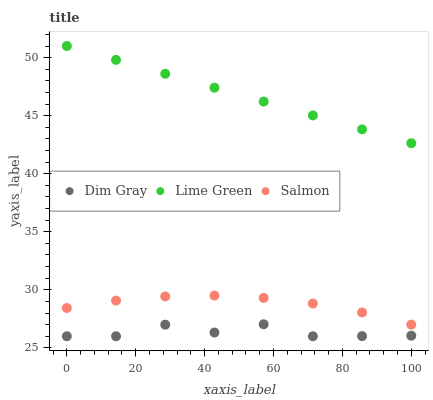Does Dim Gray have the minimum area under the curve?
Answer yes or no. Yes. Does Lime Green have the maximum area under the curve?
Answer yes or no. Yes. Does Lime Green have the minimum area under the curve?
Answer yes or no. No. Does Dim Gray have the maximum area under the curve?
Answer yes or no. No. Is Lime Green the smoothest?
Answer yes or no. Yes. Is Dim Gray the roughest?
Answer yes or no. Yes. Is Dim Gray the smoothest?
Answer yes or no. No. Is Lime Green the roughest?
Answer yes or no. No. Does Dim Gray have the lowest value?
Answer yes or no. Yes. Does Lime Green have the lowest value?
Answer yes or no. No. Does Lime Green have the highest value?
Answer yes or no. Yes. Does Dim Gray have the highest value?
Answer yes or no. No. Is Salmon less than Lime Green?
Answer yes or no. Yes. Is Lime Green greater than Salmon?
Answer yes or no. Yes. Does Salmon intersect Lime Green?
Answer yes or no. No. 